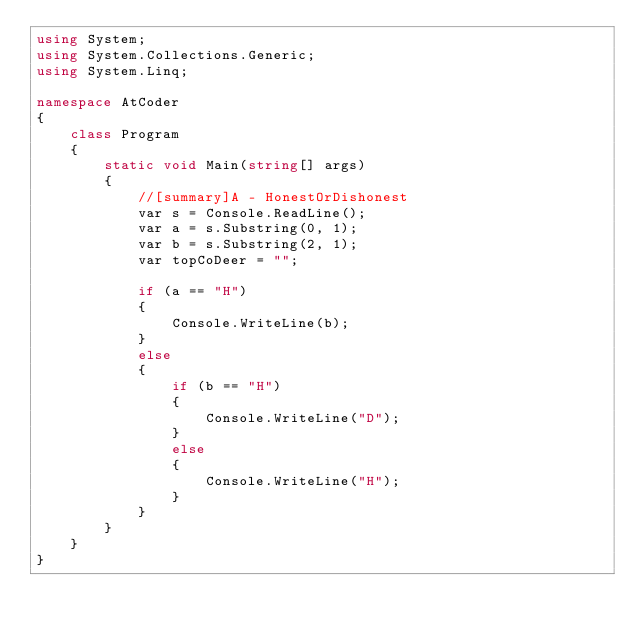Convert code to text. <code><loc_0><loc_0><loc_500><loc_500><_C#_>using System;
using System.Collections.Generic;
using System.Linq;

namespace AtCoder
{
    class Program
    {
        static void Main(string[] args)
        {
            //[summary]A - HonestOrDishonest
            var s = Console.ReadLine();
            var a = s.Substring(0, 1);
            var b = s.Substring(2, 1);
            var topCoDeer = "";

            if (a == "H")
            {
                Console.WriteLine(b);
            }
            else
            {
                if (b == "H")
                {
                    Console.WriteLine("D");
                }
                else
                {
                    Console.WriteLine("H");
                }
            }
        }
    }
}</code> 